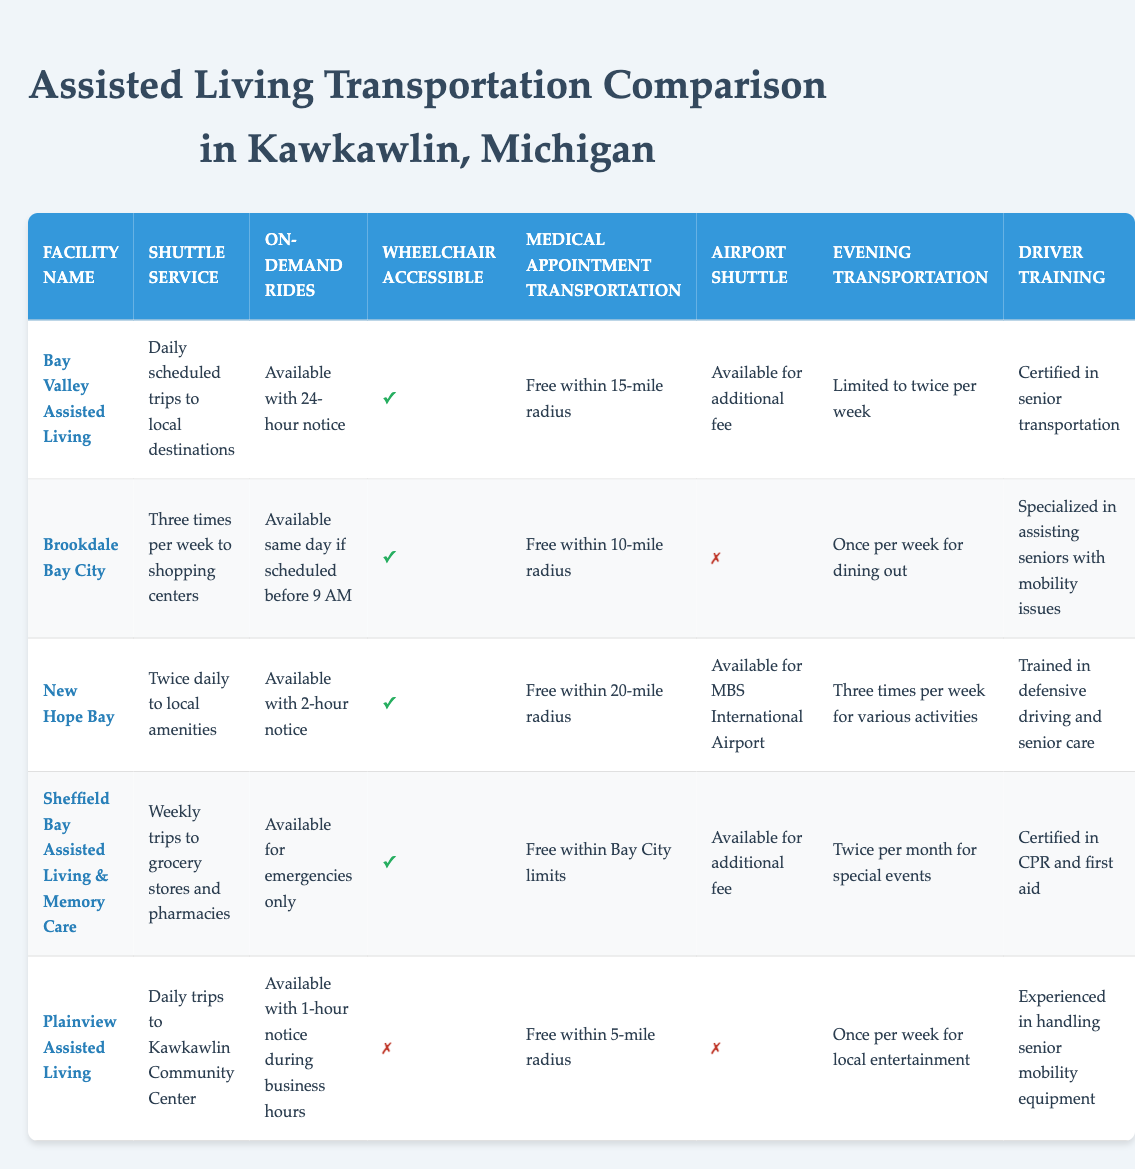What type of shuttle service does New Hope Bay provide? The table indicates that New Hope Bay offers "Twice daily to local amenities" as their shuttle service. This information can be directly found in the row corresponding to New Hope Bay under the "Shuttle Service" column.
Answer: Twice daily to local amenities Which facilities provide on-demand rides with fewer than 2 hours' notice? To answer this, we look at the "On-Demand Rides" column in each row. The facilities that provide on-demand rides with less than 2 hours' notice are Bay Valley Assisted Living (24-hour notice) and New Hope Bay (2-hour notice). Plainview Assisted Living provides rides with 1-hour notice during business hours. Therefore, the only one meeting the requirement for under 2-hour notice is Plainview.
Answer: Plainview Assisted Living Is there a facility that provides medical transportation with no fee for a radius larger than 15 miles? By checking the "Medical Appointment Transportation" column, we see that New Hope Bay offers free transportation within a 20-mile radius, which is larger than 15 miles. The other facilities either have a smaller radius or charge fees.
Answer: Yes, New Hope Bay How many facilities offer evening transportation more than twice a week? We need to count the rows for the "Evening Transportation" column. New Hope Bay has three times a week for various activities, while the others have fewer occurrences. Thus, only one facility meets the criteria.
Answer: 1 Which assisted living facility lacks wheelchair-accessible vehicles? By examining the "Wheelchair Accessible" column, we find that Plainview Assisted Living is marked with a cross, indicating that it does not provide wheelchair-accessible vehicles. The other facilities all do.
Answer: Plainview Assisted Living What is the average number of days per week that transportation services are provided for evening activities across all facilities? We sum the weekly evening transportation limits: Bay Valley (2), Brookdale Bay City (1), New Hope Bay (3), Sheffield Bay (2), and Plainview (1) leading to a total of 9. Since there are 5 facilities, we calculate the average as 9 divided by 5, which equals 1.8.
Answer: 1.8 Does any facility offer free medical transportation without limitations on distance? Reviewing the "Medical Appointment Transportation" column, all facilities have some form of distance limit. No facility offers unlimited free medical transportation; hence the answer is based on the review of all entries.
Answer: No Which two facilities have an airport shuttle available? We look at the "Airport Shuttle" column for each facility. The facilities offering airport shuttle services are New Hope Bay and Bay Valley Assisted Living. Both are marked as available, thus they fulfill the criteria.
Answer: New Hope Bay and Bay Valley Assisted Living 